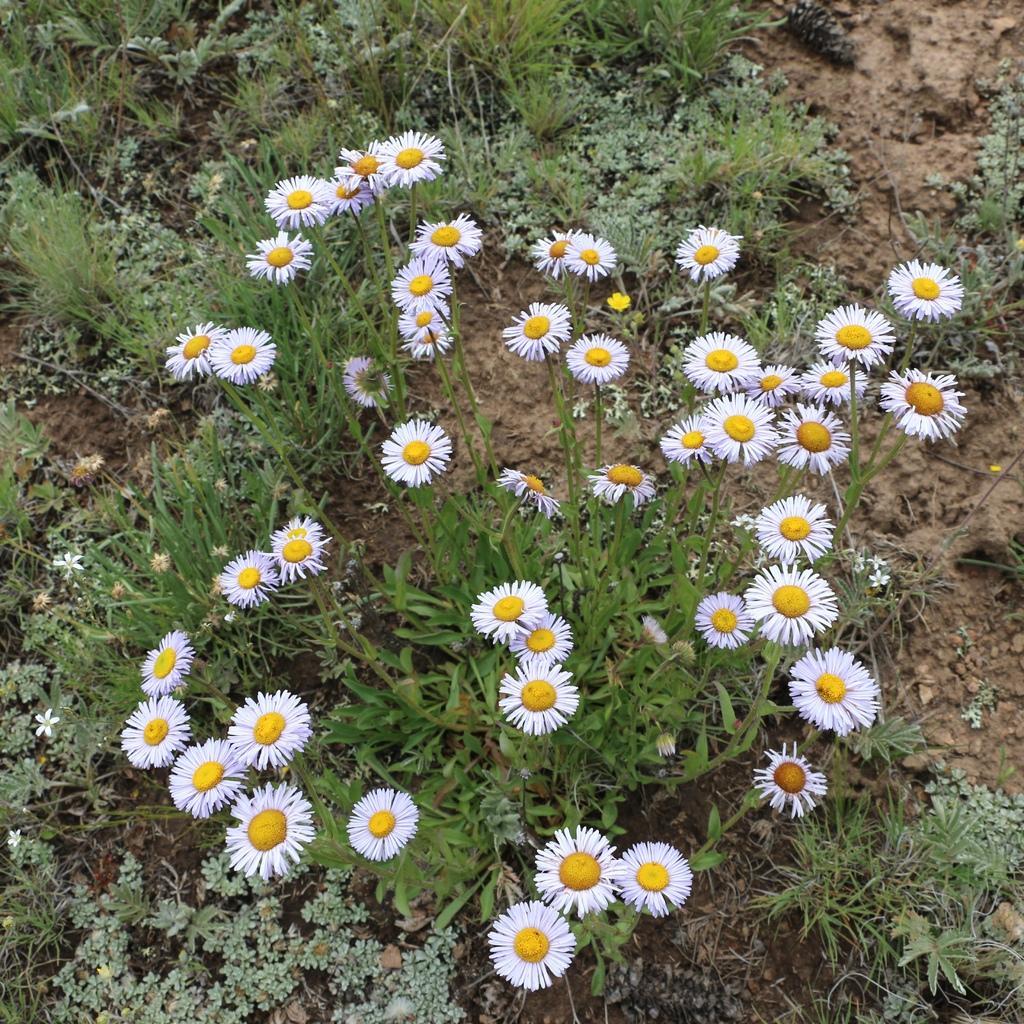How would you summarize this image in a sentence or two? In this picture there are flower plants in the center of the image, there is greenery in the image. 